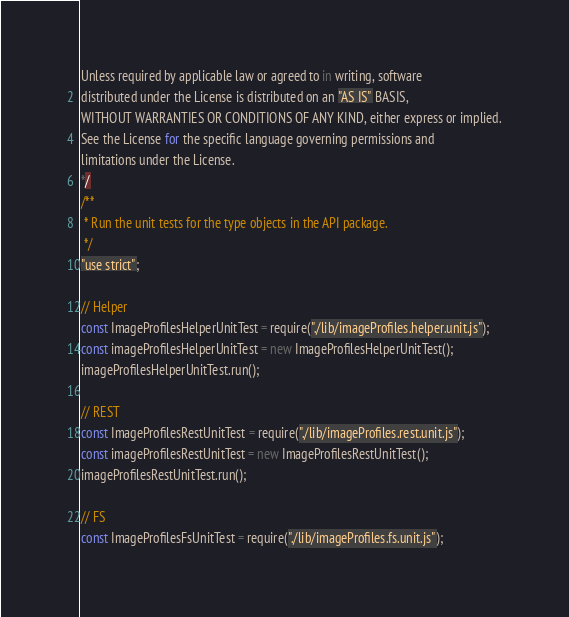<code> <loc_0><loc_0><loc_500><loc_500><_JavaScript_>
Unless required by applicable law or agreed to in writing, software
distributed under the License is distributed on an "AS IS" BASIS,
WITHOUT WARRANTIES OR CONDITIONS OF ANY KIND, either express or implied.
See the License for the specific language governing permissions and
limitations under the License.
*/
/**
 * Run the unit tests for the type objects in the API package.
 */
"use strict";

// Helper
const ImageProfilesHelperUnitTest = require("./lib/imageProfiles.helper.unit.js");
const imageProfilesHelperUnitTest = new ImageProfilesHelperUnitTest();
imageProfilesHelperUnitTest.run();

// REST
const ImageProfilesRestUnitTest = require("./lib/imageProfiles.rest.unit.js");
const imageProfilesRestUnitTest = new ImageProfilesRestUnitTest();
imageProfilesRestUnitTest.run();

// FS
const ImageProfilesFsUnitTest = require("./lib/imageProfiles.fs.unit.js");</code> 